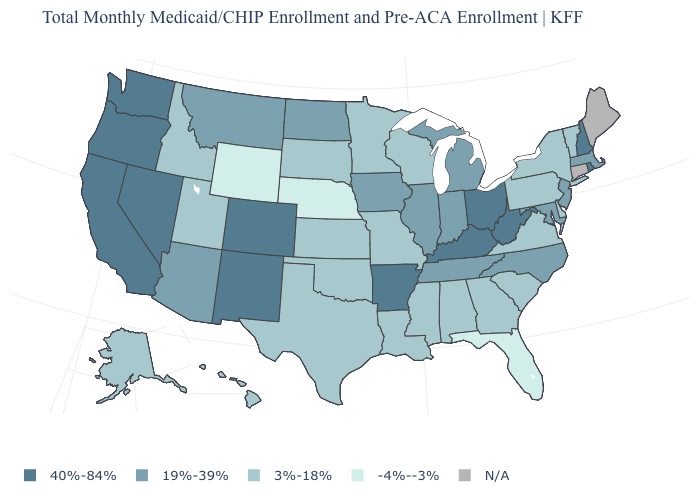What is the lowest value in states that border Rhode Island?
Short answer required. 19%-39%. Name the states that have a value in the range N/A?
Be succinct. Connecticut, Maine. Name the states that have a value in the range -4%--3%?
Answer briefly. Florida, Nebraska, Wyoming. What is the value of Montana?
Answer briefly. 19%-39%. Among the states that border North Carolina , which have the lowest value?
Quick response, please. Georgia, South Carolina, Virginia. Which states have the lowest value in the USA?
Answer briefly. Florida, Nebraska, Wyoming. Does Vermont have the highest value in the USA?
Short answer required. No. What is the value of Louisiana?
Keep it brief. 3%-18%. Name the states that have a value in the range 3%-18%?
Write a very short answer. Alabama, Alaska, Delaware, Georgia, Hawaii, Idaho, Kansas, Louisiana, Minnesota, Mississippi, Missouri, New York, Oklahoma, Pennsylvania, South Carolina, South Dakota, Texas, Utah, Vermont, Virginia, Wisconsin. What is the lowest value in states that border Michigan?
Give a very brief answer. 3%-18%. What is the value of Missouri?
Concise answer only. 3%-18%. What is the lowest value in states that border Florida?
Short answer required. 3%-18%. Does the map have missing data?
Answer briefly. Yes. What is the value of North Carolina?
Concise answer only. 19%-39%. Among the states that border Nebraska , does Kansas have the lowest value?
Concise answer only. No. 